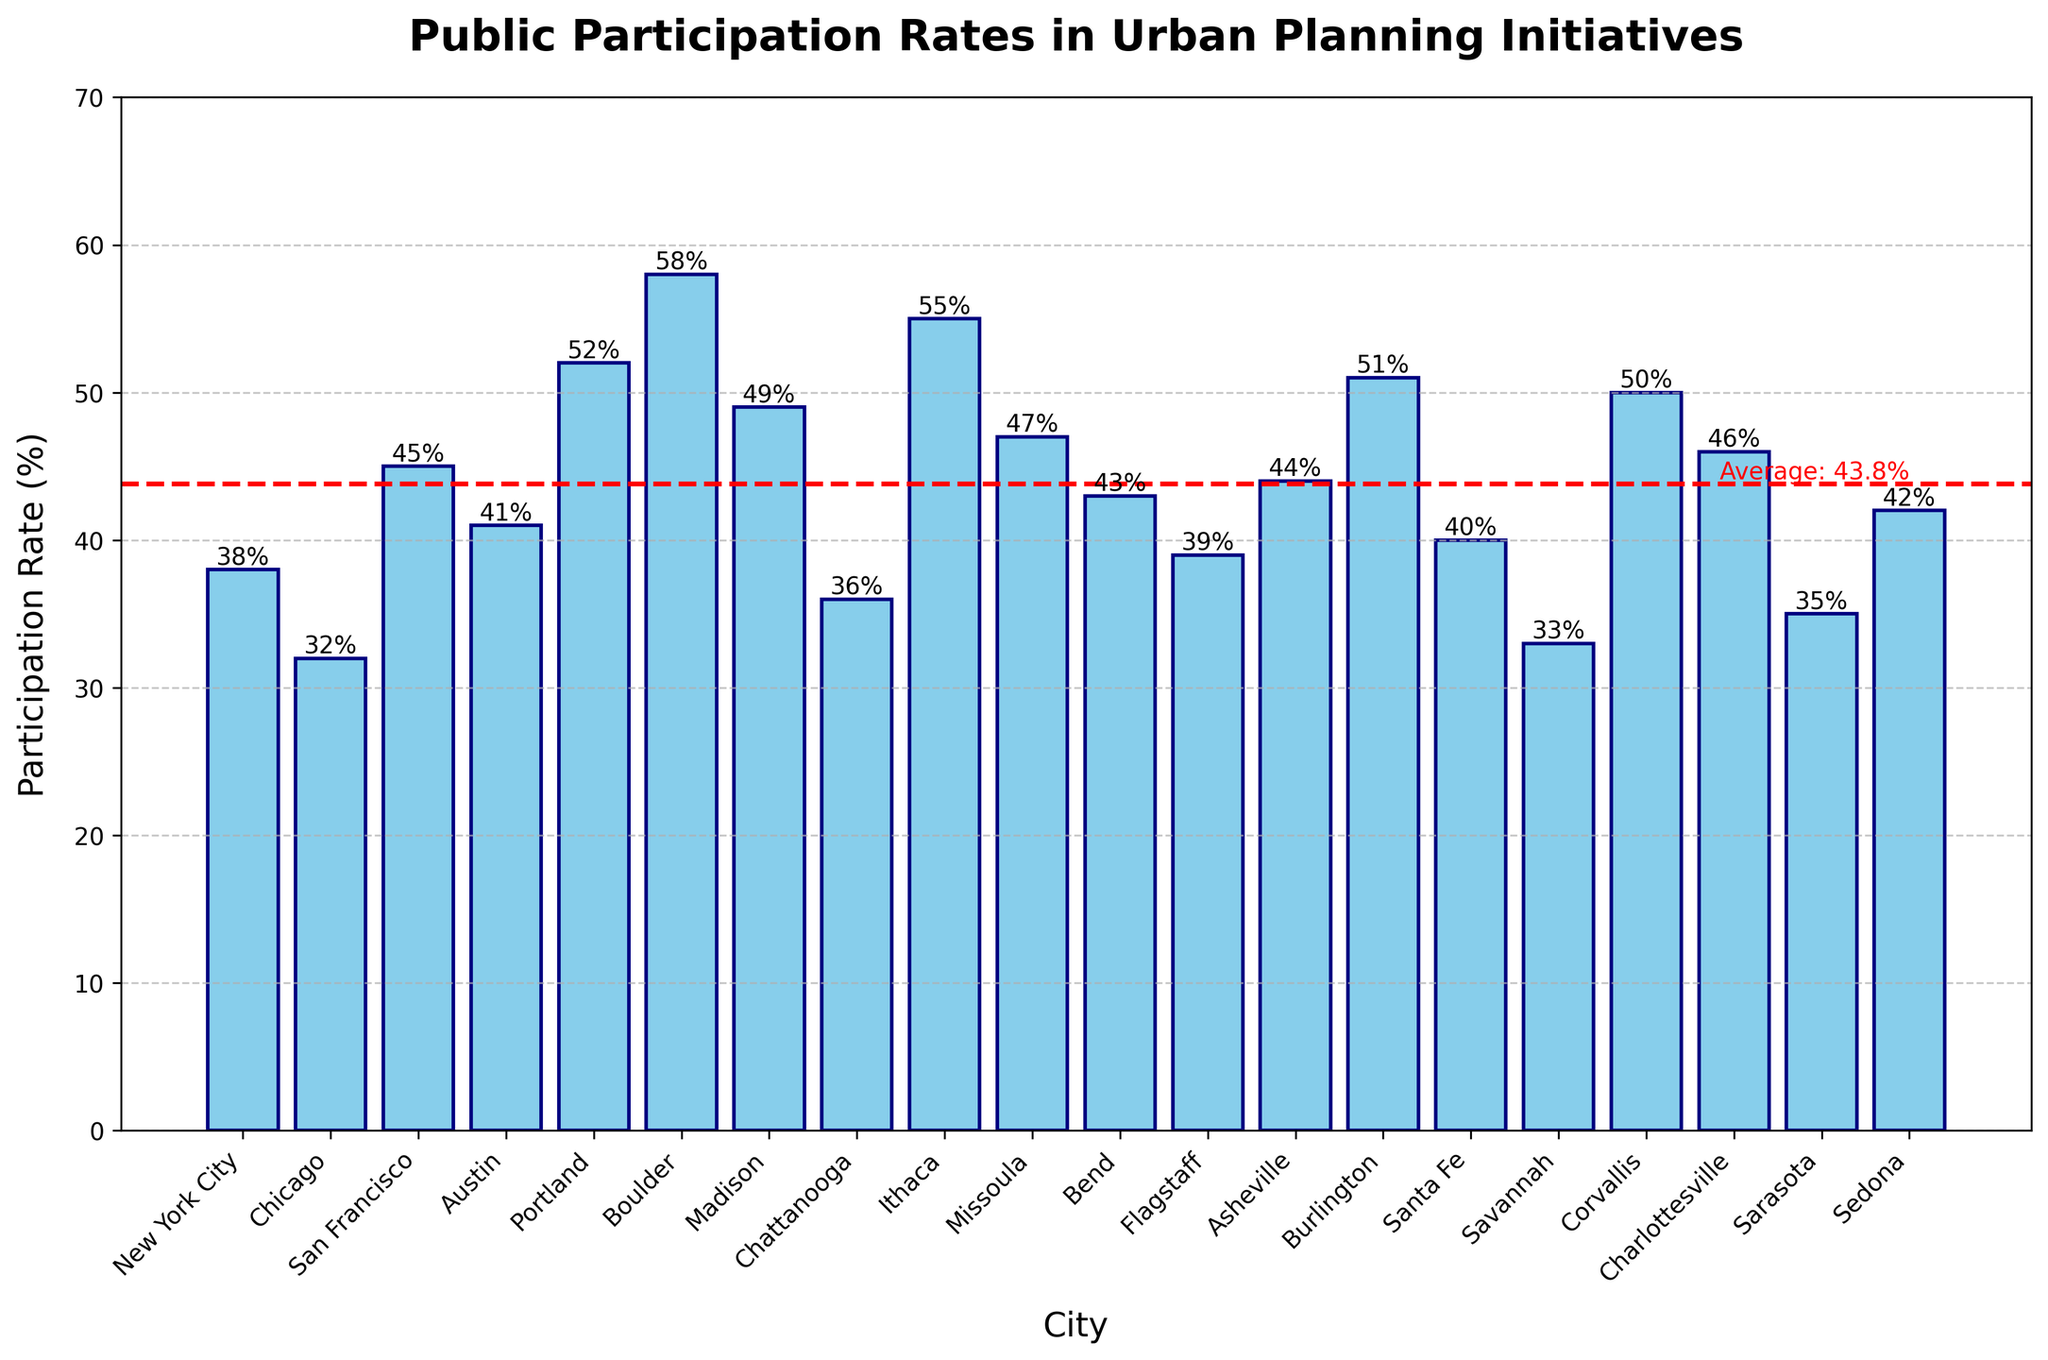Which city has the highest public participation rate in urban planning initiatives? By observing the bars and their corresponding height, Boulder has the highest participation rate at 58%.
Answer: Boulder Which city has the lowest public participation rate? By comparing the heights of all the bars, Savannah has the lowest participation rate at 33%.
Answer: Savannah What is the average public participation rate across all cities? The average is shown as a red dashed line, and the value next to it reads as 43.4%.
Answer: 43.4% How does San Francisco's participation rate compare to that of New York City? San Francisco has a higher participation rate (45%) compared to New York City (38%) by reading the heights of the respective bars.
Answer: San Francisco is higher Which cities have participation rates higher than 50%? By identifying bars taller than the average (red line at 43.4%) and higher than the 50% line, the cities are: Boulder (58%), Portland (52%), and Ithaca (55%).
Answer: Boulder, Portland, Ithaca What is the difference in participation rates between Chattanooga and Asheville? Chattanooga has a rate of 36%, and Asheville has 44%. The difference is 44% - 36% = 8%.
Answer: 8% What is the median participation rate of the cities? To find the median, list the rates in ascending order: [32, 33, 35, 36, 38, 39, 40, 41, 42, 43, 44, 45, 46, 47, 49, 50, 51, 52, 55, 58]. The median (middle value) of these 20 rates is the average of the 10th (43) and 11th (44) values, so (43 + 44)/2 = 43.5%.
Answer: 43.5% Which cities have participation rates close to the average rate? The average (shown by a red dashed line) is 43.4%. Cities near this average rate are Bend (43%) and Flagstaff (39%), with Bend being the closest.
Answer: Bend, Flagstaff How many cities have participation rates below the average rate? By observing the bars below the red dashed line, the count is 10 cities.
Answer: 10 What visual elements help distinguish the average participation rate in the chart? The average participation rate is highlighted with a red dashed line running horizontally across the chart, and it is also annotated with a text label "Average: 43.4%".
Answer: Red dashed line and text label 